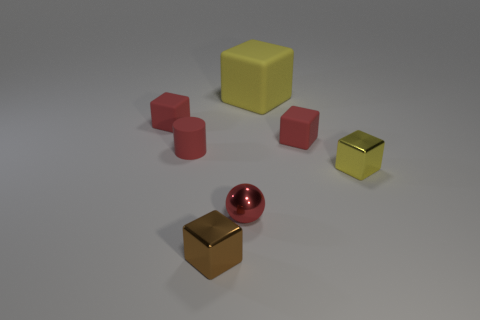Add 1 gray rubber objects. How many objects exist? 8 Subtract all blocks. How many objects are left? 2 Add 6 small red spheres. How many small red spheres are left? 7 Add 1 tiny green objects. How many tiny green objects exist? 1 Subtract 0 blue spheres. How many objects are left? 7 Subtract all red matte cylinders. Subtract all red cylinders. How many objects are left? 5 